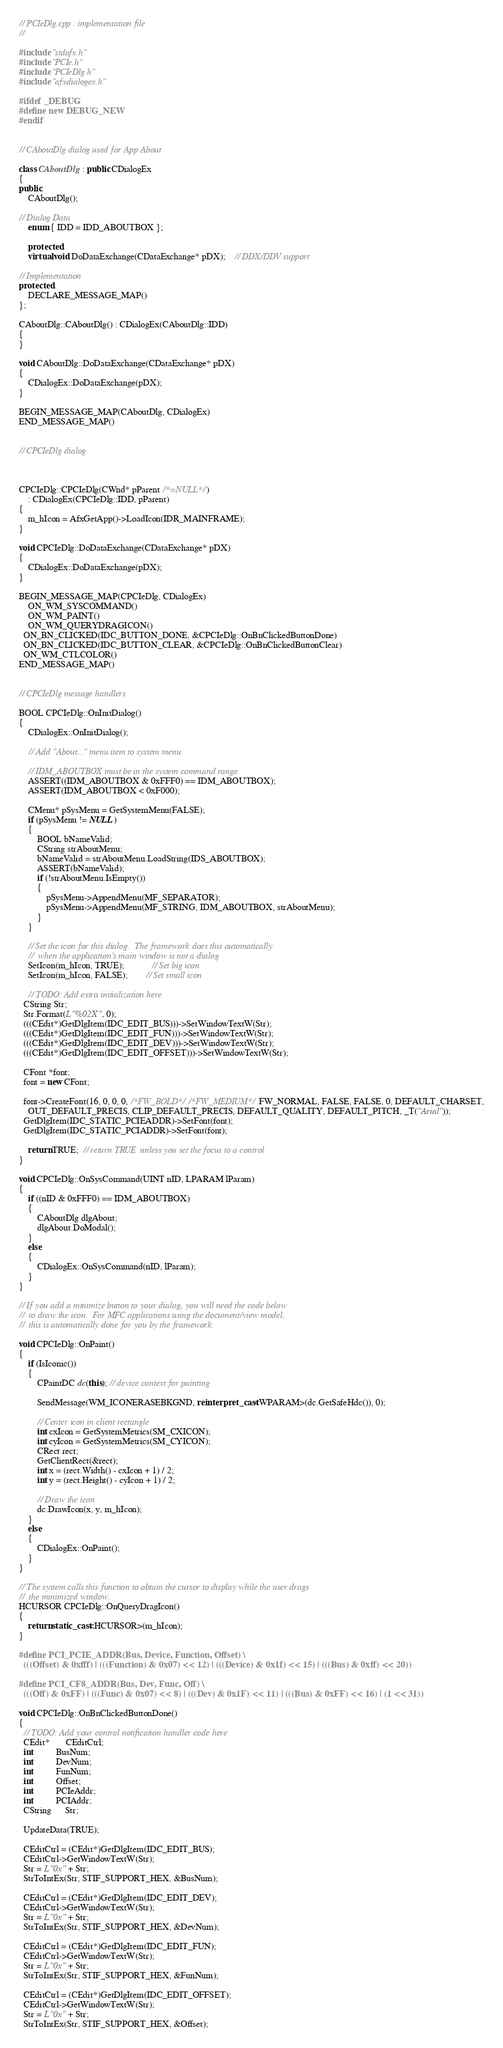<code> <loc_0><loc_0><loc_500><loc_500><_C++_>
// PCIeDlg.cpp : implementation file
//

#include "stdafx.h"
#include "PCIe.h"
#include "PCIeDlg.h"
#include "afxdialogex.h"

#ifdef _DEBUG
#define new DEBUG_NEW
#endif


// CAboutDlg dialog used for App About

class CAboutDlg : public CDialogEx
{
public:
	CAboutDlg();

// Dialog Data
	enum { IDD = IDD_ABOUTBOX };

	protected:
	virtual void DoDataExchange(CDataExchange* pDX);    // DDX/DDV support

// Implementation
protected:
	DECLARE_MESSAGE_MAP()
};

CAboutDlg::CAboutDlg() : CDialogEx(CAboutDlg::IDD)
{
}

void CAboutDlg::DoDataExchange(CDataExchange* pDX)
{
	CDialogEx::DoDataExchange(pDX);
}

BEGIN_MESSAGE_MAP(CAboutDlg, CDialogEx)
END_MESSAGE_MAP()


// CPCIeDlg dialog



CPCIeDlg::CPCIeDlg(CWnd* pParent /*=NULL*/)
	: CDialogEx(CPCIeDlg::IDD, pParent)
{
	m_hIcon = AfxGetApp()->LoadIcon(IDR_MAINFRAME);
}

void CPCIeDlg::DoDataExchange(CDataExchange* pDX)
{
	CDialogEx::DoDataExchange(pDX);
}

BEGIN_MESSAGE_MAP(CPCIeDlg, CDialogEx)
	ON_WM_SYSCOMMAND()
	ON_WM_PAINT()
	ON_WM_QUERYDRAGICON()
  ON_BN_CLICKED(IDC_BUTTON_DONE, &CPCIeDlg::OnBnClickedButtonDone)
  ON_BN_CLICKED(IDC_BUTTON_CLEAR, &CPCIeDlg::OnBnClickedButtonClear)
  ON_WM_CTLCOLOR()
END_MESSAGE_MAP()


// CPCIeDlg message handlers

BOOL CPCIeDlg::OnInitDialog()
{
	CDialogEx::OnInitDialog();

	// Add "About..." menu item to system menu.

	// IDM_ABOUTBOX must be in the system command range.
	ASSERT((IDM_ABOUTBOX & 0xFFF0) == IDM_ABOUTBOX);
	ASSERT(IDM_ABOUTBOX < 0xF000);

	CMenu* pSysMenu = GetSystemMenu(FALSE);
	if (pSysMenu != NULL)
	{
		BOOL bNameValid;
		CString strAboutMenu;
		bNameValid = strAboutMenu.LoadString(IDS_ABOUTBOX);
		ASSERT(bNameValid);
		if (!strAboutMenu.IsEmpty())
		{
			pSysMenu->AppendMenu(MF_SEPARATOR);
			pSysMenu->AppendMenu(MF_STRING, IDM_ABOUTBOX, strAboutMenu);
		}
	}

	// Set the icon for this dialog.  The framework does this automatically
	//  when the application's main window is not a dialog
	SetIcon(m_hIcon, TRUE);			// Set big icon
	SetIcon(m_hIcon, FALSE);		// Set small icon

	// TODO: Add extra initialization here
  CString Str;
  Str.Format(L"%02X", 0);
  (((CEdit*)GetDlgItem(IDC_EDIT_BUS)))->SetWindowTextW(Str);
  (((CEdit*)GetDlgItem(IDC_EDIT_FUN)))->SetWindowTextW(Str);
  (((CEdit*)GetDlgItem(IDC_EDIT_DEV)))->SetWindowTextW(Str);
  (((CEdit*)GetDlgItem(IDC_EDIT_OFFSET)))->SetWindowTextW(Str);

  CFont *font;
  font = new CFont;

  font->CreateFont(16, 0, 0, 0, /*FW_BOLD*//*FW_MEDIUM*/FW_NORMAL, FALSE, FALSE, 0, DEFAULT_CHARSET,
    OUT_DEFAULT_PRECIS, CLIP_DEFAULT_PRECIS, DEFAULT_QUALITY, DEFAULT_PITCH, _T("Arial"));
  GetDlgItem(IDC_STATIC_PCIEADDR)->SetFont(font);
  GetDlgItem(IDC_STATIC_PCIADDR)->SetFont(font);

	return TRUE;  // return TRUE  unless you set the focus to a control
}

void CPCIeDlg::OnSysCommand(UINT nID, LPARAM lParam)
{
	if ((nID & 0xFFF0) == IDM_ABOUTBOX)
	{
		CAboutDlg dlgAbout;
		dlgAbout.DoModal();
	}
	else
	{
		CDialogEx::OnSysCommand(nID, lParam);
	}
}

// If you add a minimize button to your dialog, you will need the code below
//  to draw the icon.  For MFC applications using the document/view model,
//  this is automatically done for you by the framework.

void CPCIeDlg::OnPaint()
{
	if (IsIconic())
	{
		CPaintDC dc(this); // device context for painting

		SendMessage(WM_ICONERASEBKGND, reinterpret_cast<WPARAM>(dc.GetSafeHdc()), 0);

		// Center icon in client rectangle
		int cxIcon = GetSystemMetrics(SM_CXICON);
		int cyIcon = GetSystemMetrics(SM_CYICON);
		CRect rect;
		GetClientRect(&rect);
		int x = (rect.Width() - cxIcon + 1) / 2;
		int y = (rect.Height() - cyIcon + 1) / 2;

		// Draw the icon
		dc.DrawIcon(x, y, m_hIcon);
	}
	else
	{
		CDialogEx::OnPaint();
	}
}

// The system calls this function to obtain the cursor to display while the user drags
//  the minimized window.
HCURSOR CPCIeDlg::OnQueryDragIcon()
{
	return static_cast<HCURSOR>(m_hIcon);
}

#define PCI_PCIE_ADDR(Bus, Device, Function, Offset) \
  (((Offset) & 0xfff) | (((Function) & 0x07) << 12) | (((Device) & 0x1f) << 15) | (((Bus) & 0xff) << 20))

#define PCI_CF8_ADDR(Bus, Dev, Func, Off) \
  (((Off) & 0xFF) | (((Func) & 0x07) << 8) | (((Dev) & 0x1F) << 11) | (((Bus) & 0xFF) << 16) | (1 << 31))

void CPCIeDlg::OnBnClickedButtonDone()
{
  // TODO: Add your control notification handler code here
  CEdit*       CEditCtrl;
  int          BusNum;
  int          DevNum;
  int          FunNum;
  int          Offset;
  int          PCIeAddr;
  int          PCIAddr;
  CString      Str;

  UpdateData(TRUE);

  CEditCtrl = (CEdit*)GetDlgItem(IDC_EDIT_BUS);
  CEditCtrl->GetWindowTextW(Str);
  Str = L"0x" + Str;
  StrToIntEx(Str, STIF_SUPPORT_HEX, &BusNum);  

  CEditCtrl = (CEdit*)GetDlgItem(IDC_EDIT_DEV);
  CEditCtrl->GetWindowTextW(Str);
  Str = L"0x" + Str;
  StrToIntEx(Str, STIF_SUPPORT_HEX, &DevNum);

  CEditCtrl = (CEdit*)GetDlgItem(IDC_EDIT_FUN);
  CEditCtrl->GetWindowTextW(Str);
  Str = L"0x" + Str;
  StrToIntEx(Str, STIF_SUPPORT_HEX, &FunNum);

  CEditCtrl = (CEdit*)GetDlgItem(IDC_EDIT_OFFSET);
  CEditCtrl->GetWindowTextW(Str);
  Str = L"0x" + Str;
  StrToIntEx(Str, STIF_SUPPORT_HEX, &Offset);
</code> 